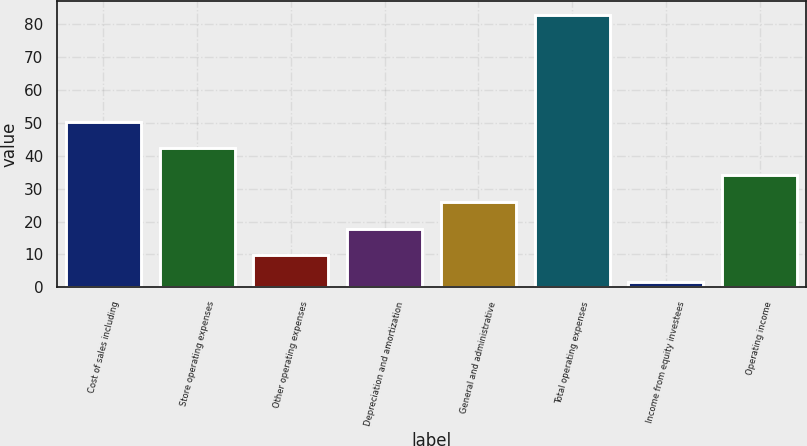<chart> <loc_0><loc_0><loc_500><loc_500><bar_chart><fcel>Cost of sales including<fcel>Store operating expenses<fcel>Other operating expenses<fcel>Depreciation and amortization<fcel>General and administrative<fcel>Total operating expenses<fcel>Income from equity investees<fcel>Operating income<nl><fcel>50.38<fcel>42.25<fcel>9.73<fcel>17.86<fcel>25.99<fcel>82.9<fcel>1.6<fcel>34.12<nl></chart> 